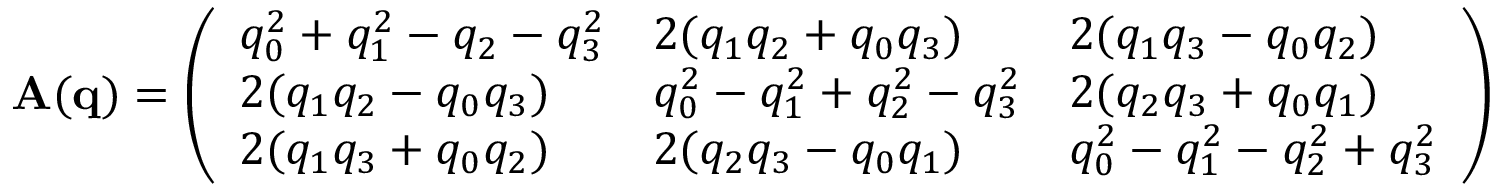<formula> <loc_0><loc_0><loc_500><loc_500>\begin{array} { r } { A ( q ) = \left ( \begin{array} { l l l } { q _ { 0 } ^ { 2 } + q _ { 1 } ^ { 2 } - q _ { 2 } - q _ { 3 } ^ { 2 } } & { 2 ( q _ { 1 } q _ { 2 } + q _ { 0 } q _ { 3 } ) } & { 2 ( q _ { 1 } q _ { 3 } - q _ { 0 } q _ { 2 } ) } \\ { 2 ( q _ { 1 } q _ { 2 } - q _ { 0 } q _ { 3 } ) } & { q _ { 0 } ^ { 2 } - q _ { 1 } ^ { 2 } + q _ { 2 } ^ { 2 } - q _ { 3 } ^ { 2 } } & { 2 ( q _ { 2 } q _ { 3 } + q _ { 0 } q _ { 1 } ) } \\ { 2 ( q _ { 1 } q _ { 3 } + q _ { 0 } q _ { 2 } ) } & { 2 ( q _ { 2 } q _ { 3 } - q _ { 0 } q _ { 1 } ) } & { q _ { 0 } ^ { 2 } - q _ { 1 } ^ { 2 } - q _ { 2 } ^ { 2 } + q _ { 3 } ^ { 2 } } \end{array} \right ) } \end{array}</formula> 